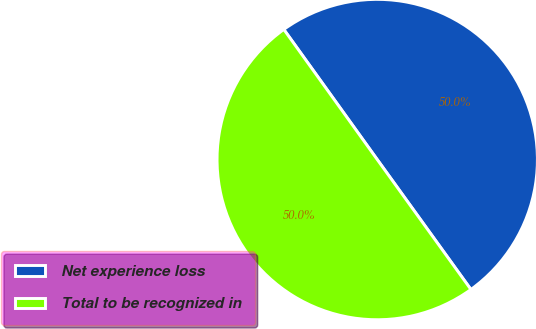<chart> <loc_0><loc_0><loc_500><loc_500><pie_chart><fcel>Net experience loss<fcel>Total to be recognized in<nl><fcel>49.97%<fcel>50.03%<nl></chart> 